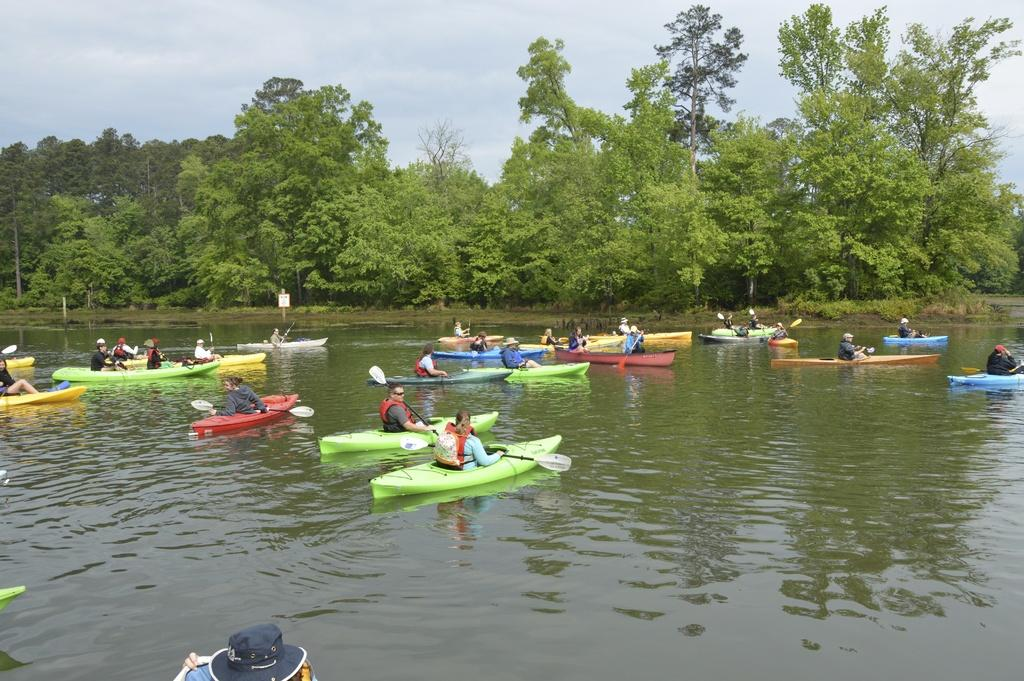What are the people in the image doing? The people are sitting on inflatable boats in the image. Where are the boats located? The boats are in the river. What can be seen in the background of the image? There are trees and the sky visible in the background of the image. What thought does the stranger have about the boat in the image? There is no stranger present in the image, so it is not possible to determine their thoughts about the boat. 